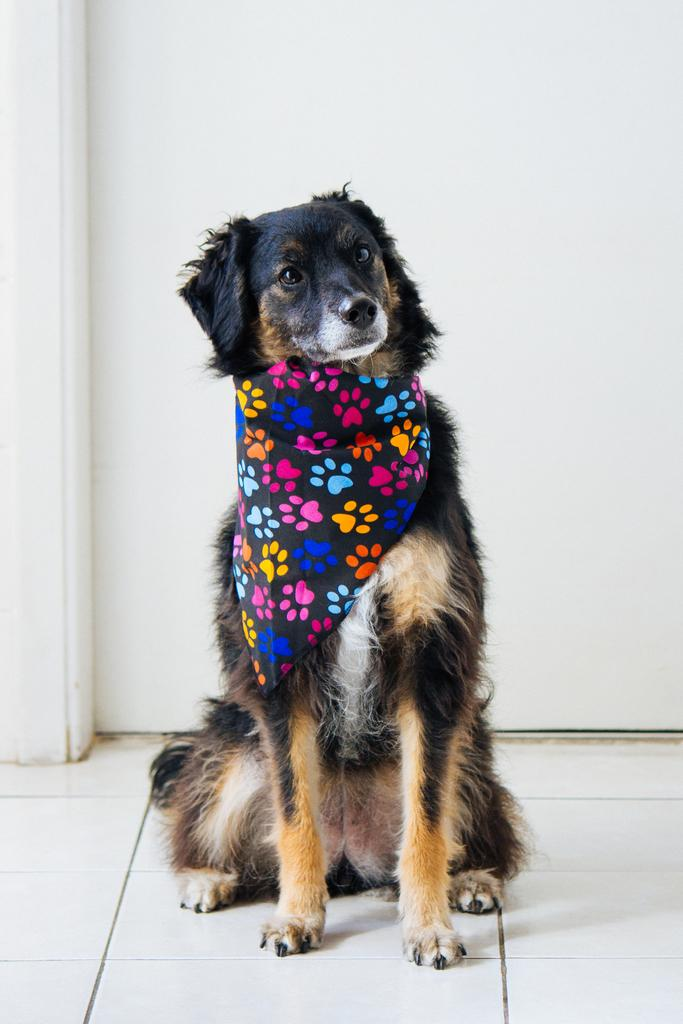What type of animal is in the image? There is a dog in the image. Where is the dog located in the image? The dog is sitting on the floor. What is attached to the dog's neck? There is a cloth tied to the dog's neck. What can be seen in the background of the image? There is a door visible in the background of the image. Can you hear the girl talking to the dog in the image? There is no girl present in the image, so it is not possible to hear her talking to the dog. 